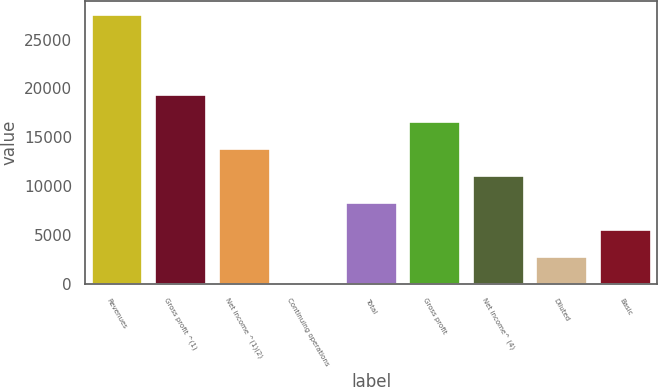Convert chart to OTSL. <chart><loc_0><loc_0><loc_500><loc_500><bar_chart><fcel>Revenues<fcel>Gross profit ^(1)<fcel>Net income ^(1)(2)<fcel>Continuing operations<fcel>Total<fcel>Gross profit<fcel>Net income^ (4)<fcel>Diluted<fcel>Basic<nl><fcel>27534<fcel>19274.1<fcel>13767.5<fcel>0.97<fcel>8260.87<fcel>16520.8<fcel>11014.2<fcel>2754.27<fcel>5507.57<nl></chart> 